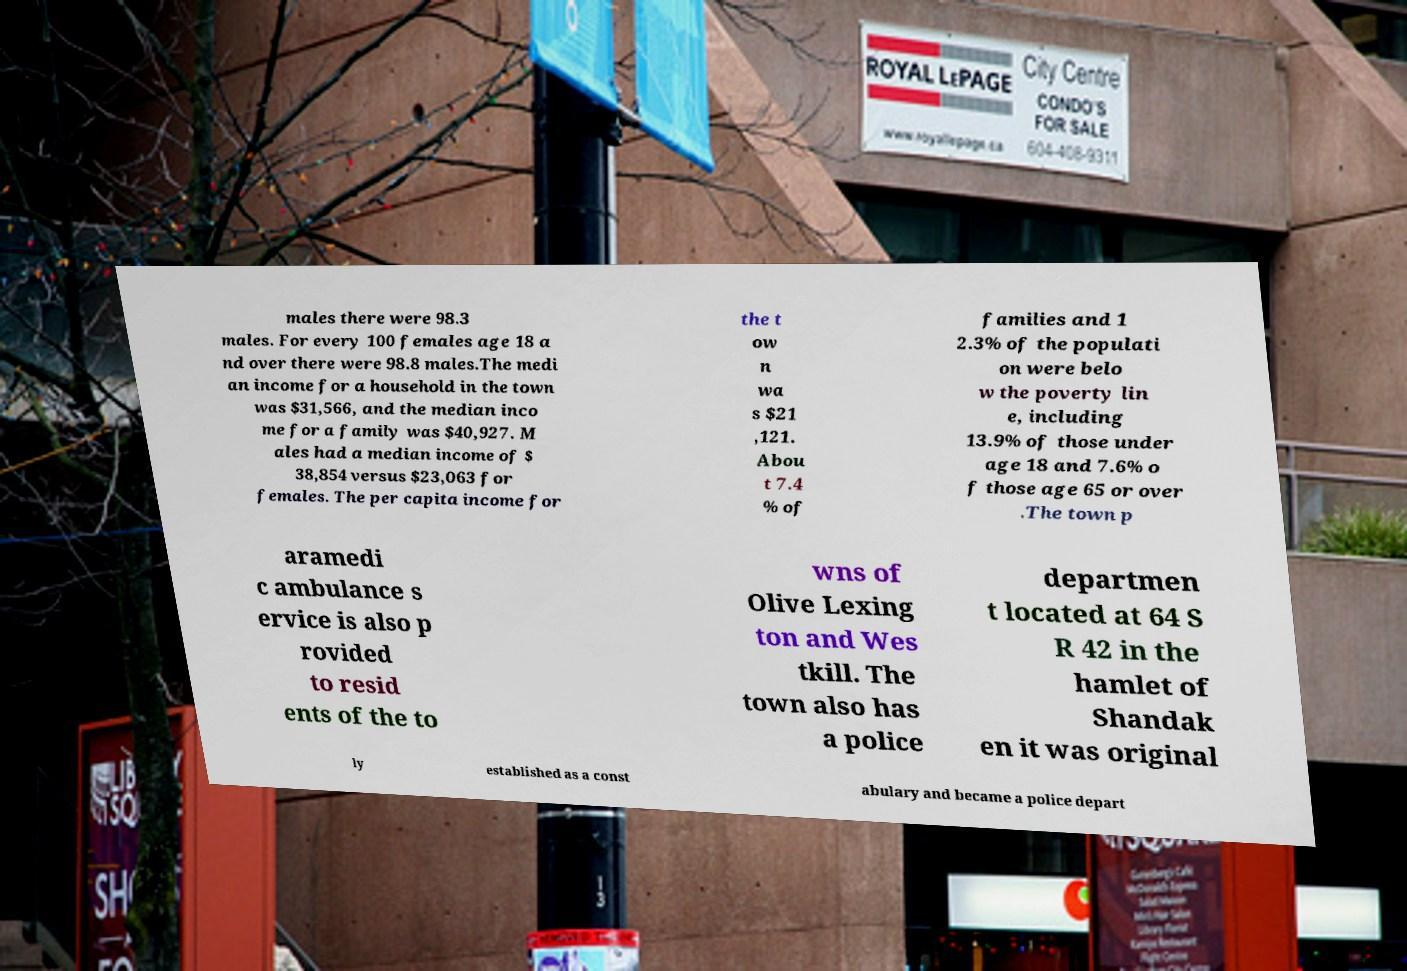I need the written content from this picture converted into text. Can you do that? males there were 98.3 males. For every 100 females age 18 a nd over there were 98.8 males.The medi an income for a household in the town was $31,566, and the median inco me for a family was $40,927. M ales had a median income of $ 38,854 versus $23,063 for females. The per capita income for the t ow n wa s $21 ,121. Abou t 7.4 % of families and 1 2.3% of the populati on were belo w the poverty lin e, including 13.9% of those under age 18 and 7.6% o f those age 65 or over .The town p aramedi c ambulance s ervice is also p rovided to resid ents of the to wns of Olive Lexing ton and Wes tkill. The town also has a police departmen t located at 64 S R 42 in the hamlet of Shandak en it was original ly established as a const abulary and became a police depart 